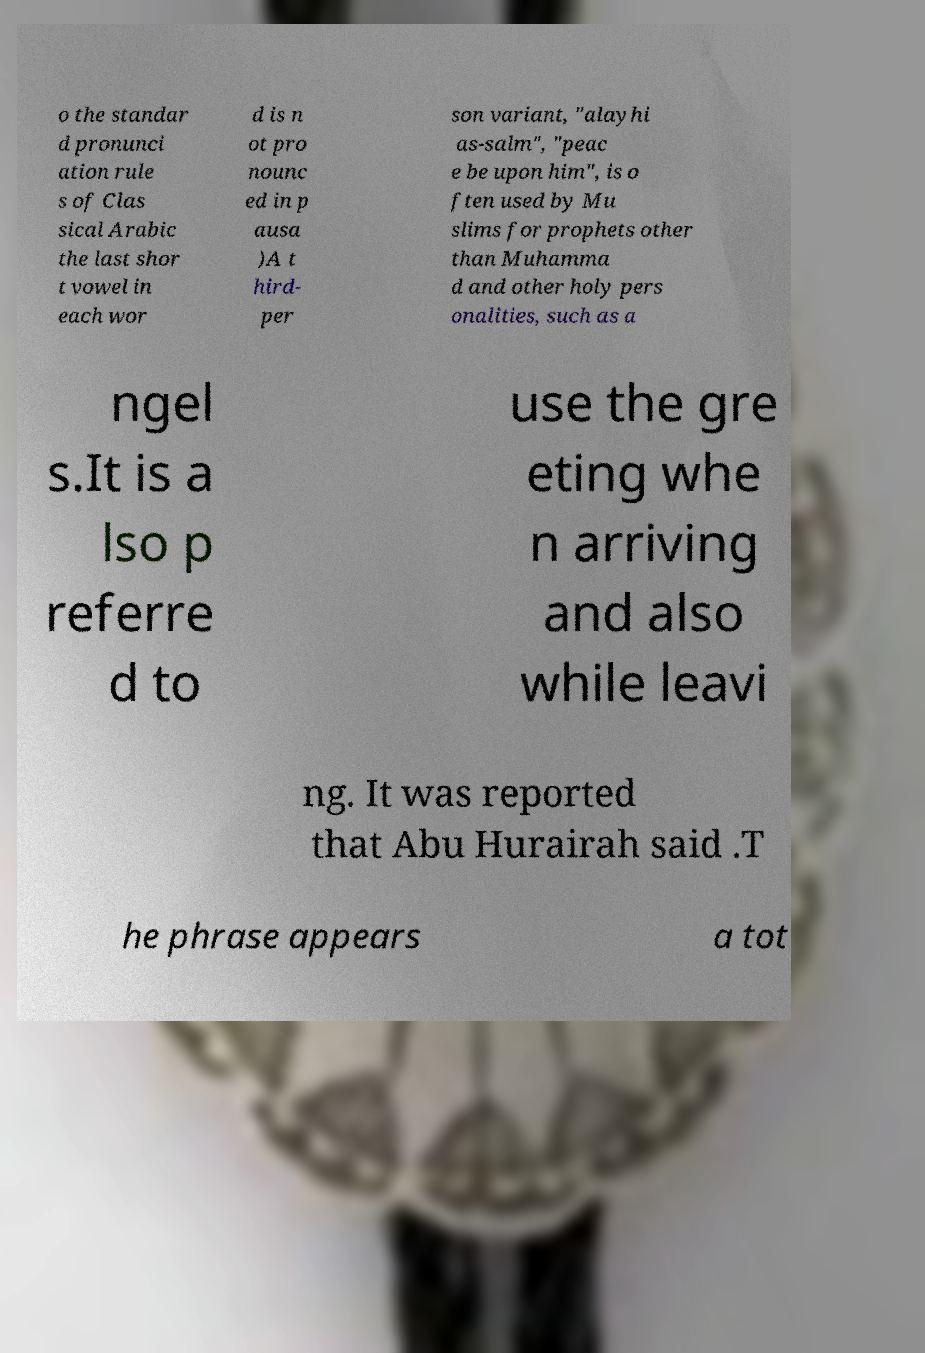What messages or text are displayed in this image? I need them in a readable, typed format. o the standar d pronunci ation rule s of Clas sical Arabic the last shor t vowel in each wor d is n ot pro nounc ed in p ausa )A t hird- per son variant, "alayhi as-salm", "peac e be upon him", is o ften used by Mu slims for prophets other than Muhamma d and other holy pers onalities, such as a ngel s.It is a lso p referre d to use the gre eting whe n arriving and also while leavi ng. It was reported that Abu Hurairah said .T he phrase appears a tot 